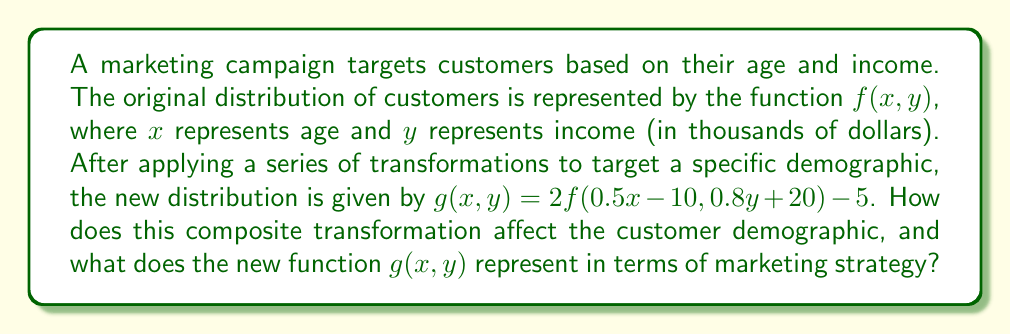Help me with this question. To understand the effects of the composite transformation, let's break down the function $g(x, y) = 2f(0.5x - 10, 0.8y + 20) - 5$ step by step:

1. Inside transformation: $f(0.5x - 10, 0.8y + 20)$
   a. For the x-coordinate (age):
      - $0.5x$ stretches the function horizontally by a factor of 2
      - $-10$ shifts the function 20 units to the right
   b. For the y-coordinate (income):
      - $0.8y$ compresses the function vertically by a factor of 1.25
      - $+20$ shifts the function 25 units down

2. Outside transformations:
   a. Multiplication by 2: This vertically stretches the entire function by a factor of 2
   b. Subtraction of 5: This shifts the entire function 5 units down

In terms of marketing strategy, these transformations mean:

1. Age targeting: The campaign now focuses on older demographics. An original age of 40 would now correspond to an age of 100 in the new distribution (solving $0.5x - 10 = 40$).

2. Income targeting: The campaign targets slightly lower income brackets. An original income of $50,000 would now correspond to $37,500 in the new distribution (solving $0.8y + 20 = 50$).

3. Overall reach: The vertical stretch by a factor of 2 indicates an increased intensity or focus on the targeted demographics.

4. Baseline adjustment: The final shift down by 5 units could represent a new minimum threshold for campaign engagement.

The new function $g(x, y)$ represents a more focused and intense marketing strategy targeting older, slightly lower-income customers, with potentially higher overall engagement rates within this specific demographic.
Answer: The composite transformation results in a marketing strategy that targets older demographics (shift right and horizontal stretch) and slightly lower income brackets (vertical compression and shift down), with increased intensity (vertical stretch) and a new baseline for engagement (final shift down). 